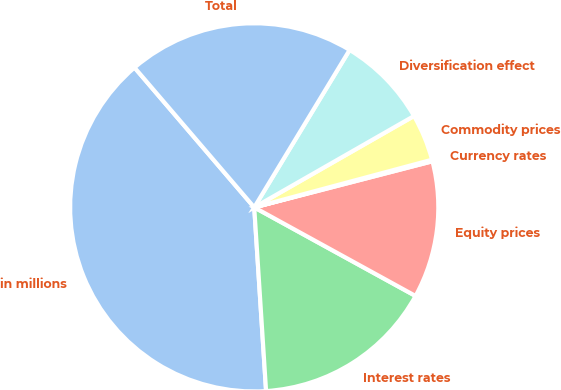Convert chart to OTSL. <chart><loc_0><loc_0><loc_500><loc_500><pie_chart><fcel>in millions<fcel>Interest rates<fcel>Equity prices<fcel>Currency rates<fcel>Commodity prices<fcel>Diversification effect<fcel>Total<nl><fcel>39.75%<fcel>15.98%<fcel>12.02%<fcel>0.14%<fcel>4.1%<fcel>8.06%<fcel>19.94%<nl></chart> 